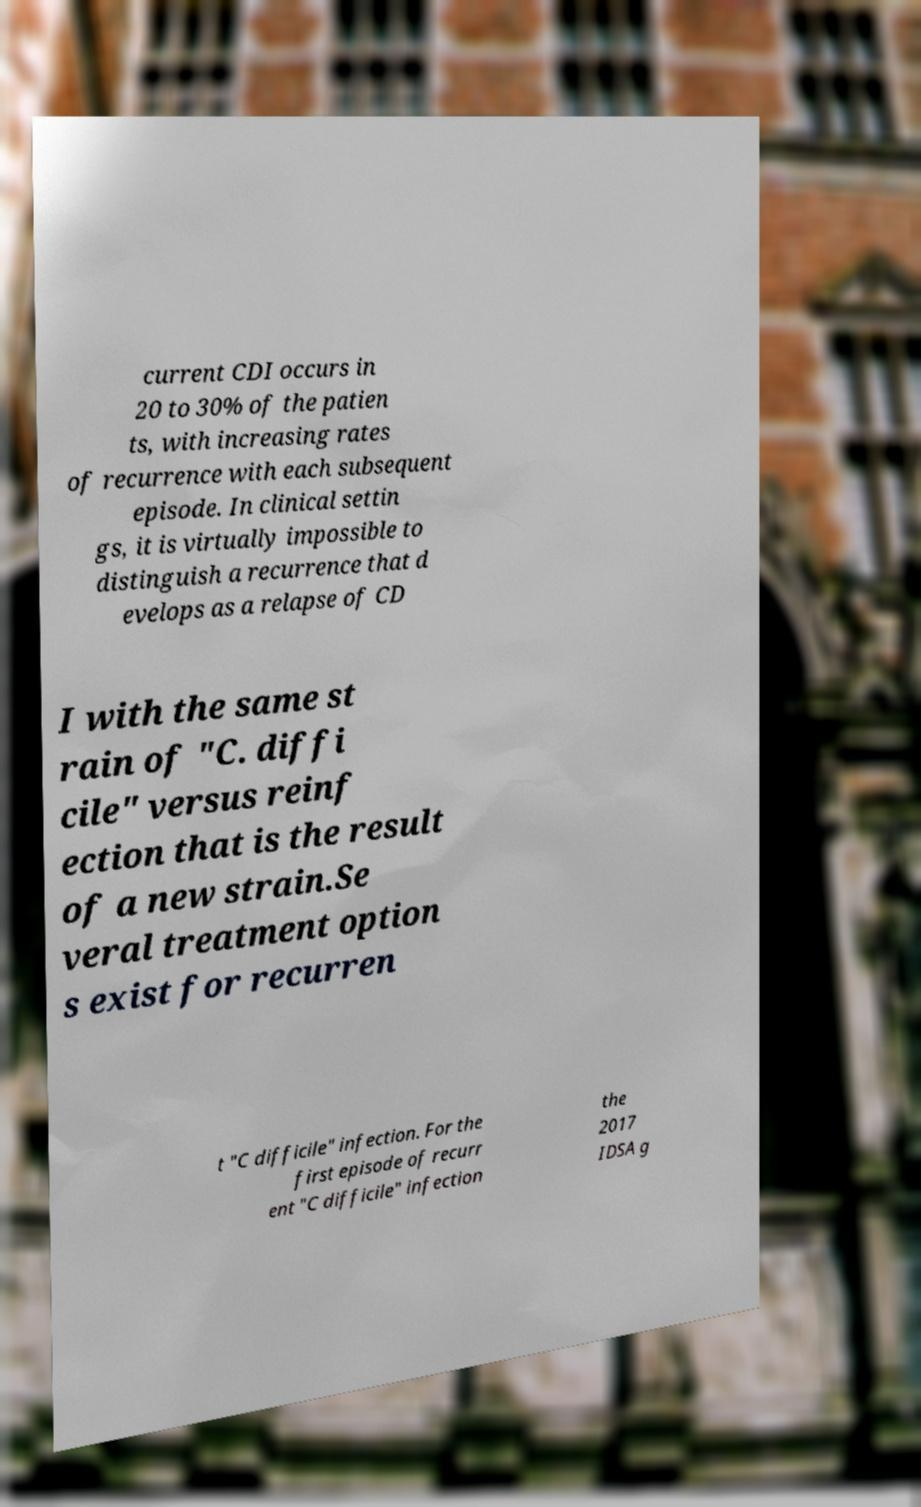Please identify and transcribe the text found in this image. current CDI occurs in 20 to 30% of the patien ts, with increasing rates of recurrence with each subsequent episode. In clinical settin gs, it is virtually impossible to distinguish a recurrence that d evelops as a relapse of CD I with the same st rain of "C. diffi cile" versus reinf ection that is the result of a new strain.Se veral treatment option s exist for recurren t "C difficile" infection. For the first episode of recurr ent "C difficile" infection the 2017 IDSA g 